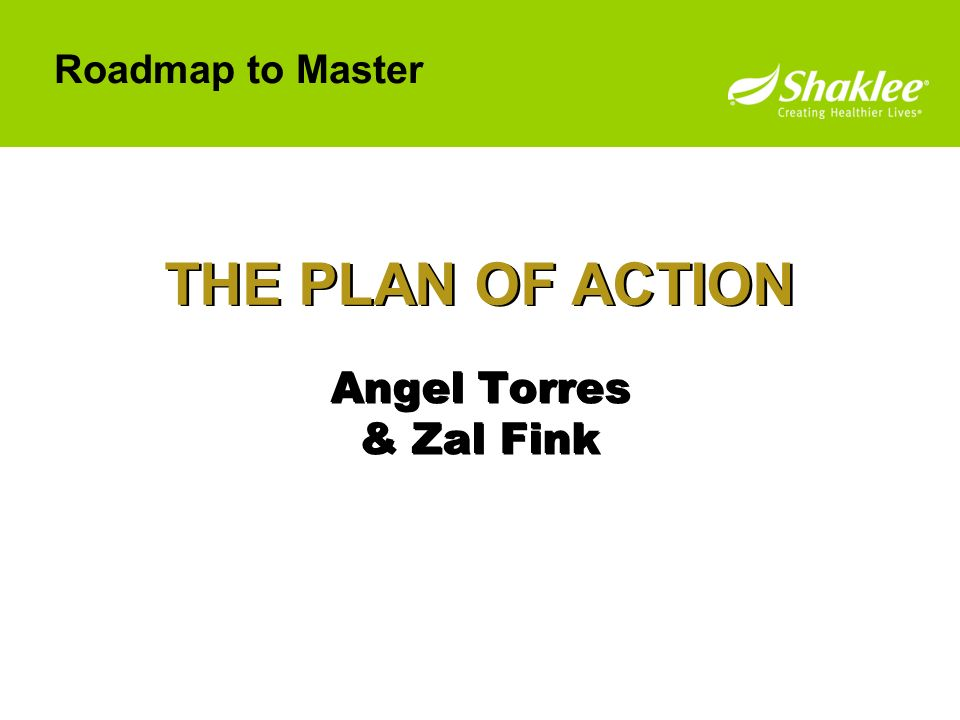What kind of audience is this slide likely aimed at? This slide is likely aimed at a professional audience, possibly within a business or corporate setting. The title 'THE PLAN OF ACTION' and the phrase 'Roadmap to Master' indicate a focus on strategic planning, which suggests the audience could be employees, team members, or stakeholders interested in understanding the steps and strategies required to achieve specific goals. The professional design and formal tone are suitable for a business environment, aiming to convey structured, actionable information to its viewers. 